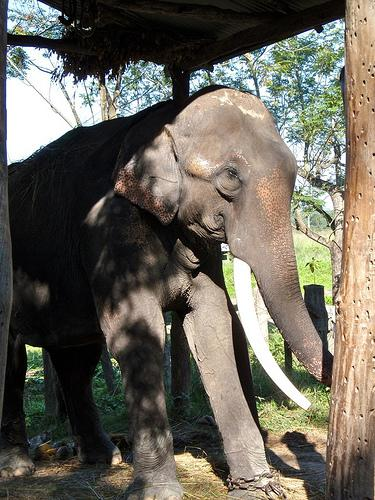Question: what is gray?
Choices:
A. Donkey.
B. Buffalo.
C. Hippo.
D. Elephant.
Answer with the letter. Answer: D Question: when was the picture taken?
Choices:
A. Sunset.
B. Daytime.
C. Sunrise.
D. At night.
Answer with the letter. Answer: B Question: who has tusks?
Choices:
A. The elephant.
B. Rhinos.
C. Walrus.
D. The bone collector.
Answer with the letter. Answer: A Question: how many trunks does the elephant have?
Choices:
A. 1.
B. 2.
C. 3.
D. 4.
Answer with the letter. Answer: A Question: what is green?
Choices:
A. Grass.
B. Money.
C. The frog.
D. The shirt.
Answer with the letter. Answer: A Question: who has big ears?
Choices:
A. The dog.
B. The man.
C. The the girl.
D. An elephant.
Answer with the letter. Answer: D 